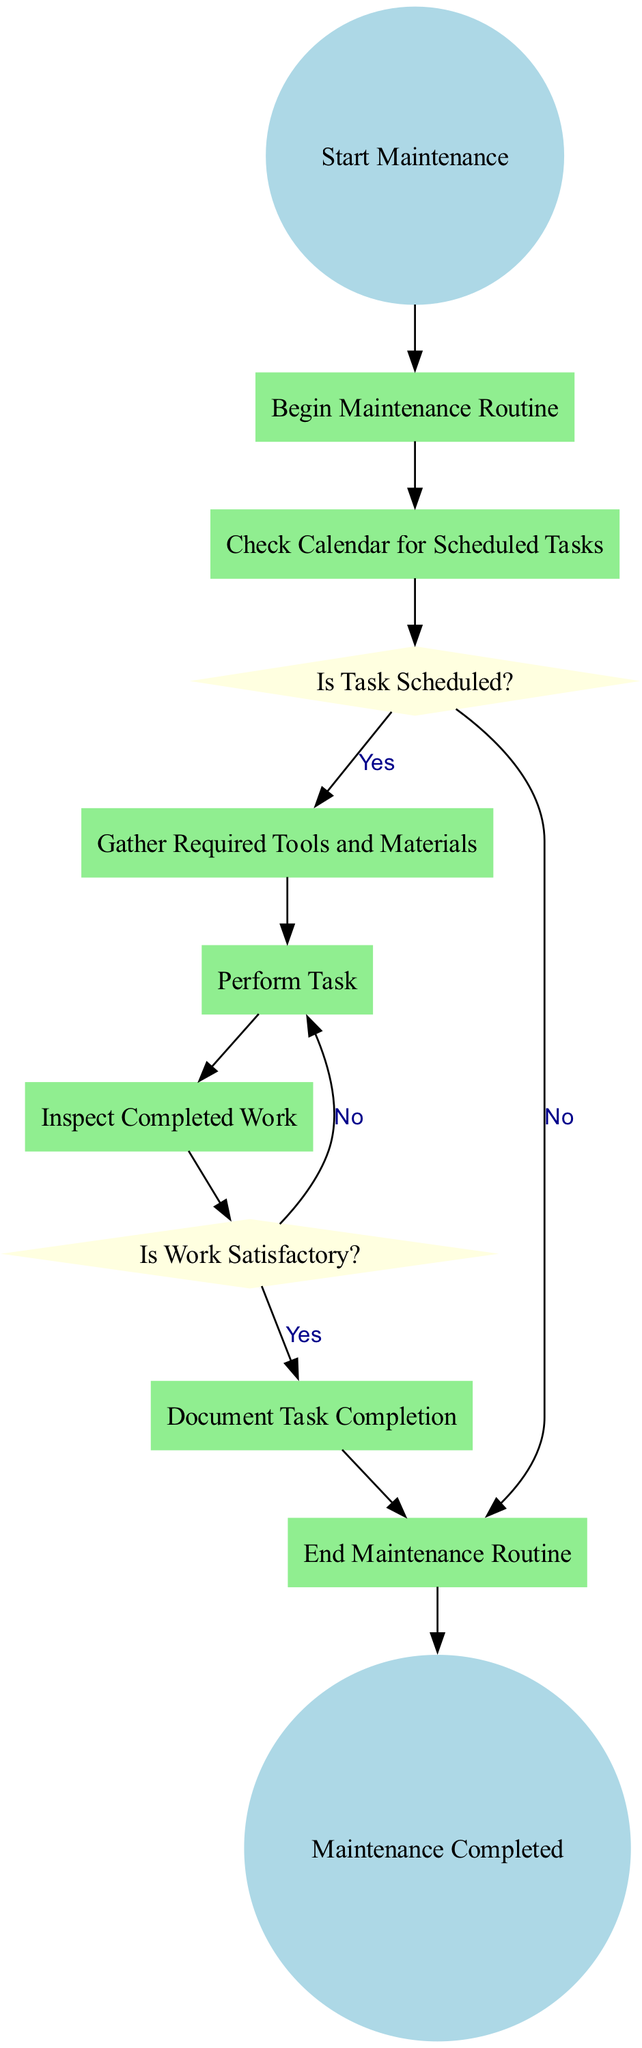What is the first action in the maintenance routine? The first action is "Begin Maintenance Routine," which is indicated directly from the start event of the diagram. This action is the entry point of the activity flow.
Answer: Begin Maintenance Routine How many decisions are present in the diagram? The diagram contains two decisions. The first decision checks if a task is scheduled, and the second checks if the work is satisfactory. These are represented by diamond-shaped nodes in the diagram.
Answer: 2 What happens if no task is scheduled? If no task is scheduled, the flow goes directly to the end event, meaning the maintenance routine is completed without any actions taken. This is shown through the flow from the decision about scheduling directly to the end node.
Answer: End Maintenance Routine What action follows the inspection of completed work? After inspecting the completed work, the next step is to check if the work is satisfactory. This is indicated by the decision node that follows the "Inspect Completed Work" action.
Answer: Is Work Satisfactory? If the work is found unsatisfactory, what happens next? If the work is unsatisfactory, the routine returns to the "Perform Task" action for rework. This is indicated by the flow that goes back to the previous action following the negative condition from the decision about work satisfaction.
Answer: Perform Task What action is taken before documenting task completion? Before documenting task completion, the action “Inspect Completed Work” must occur. This is the prerequisite action that ensures the quality of the work has been evaluated before finalizing any documentation.
Answer: Inspect Completed Work How many actions are there in total within the diagram? There are six distinct actions present in the diagram: Begin Maintenance Routine, Check Calendar for Scheduled Tasks, Gather Required Tools and Materials, Perform Task, Inspect Completed Work, and Document Task Completion. Counting these provides the total number of actions involved.
Answer: 6 What condition is checked after performing a task? After performing a task, the condition checked is "Is Work Satisfactory?" This decision determines if the work meets the required standards before proceeding to the documentation step.
Answer: Is Work Satisfactory? 